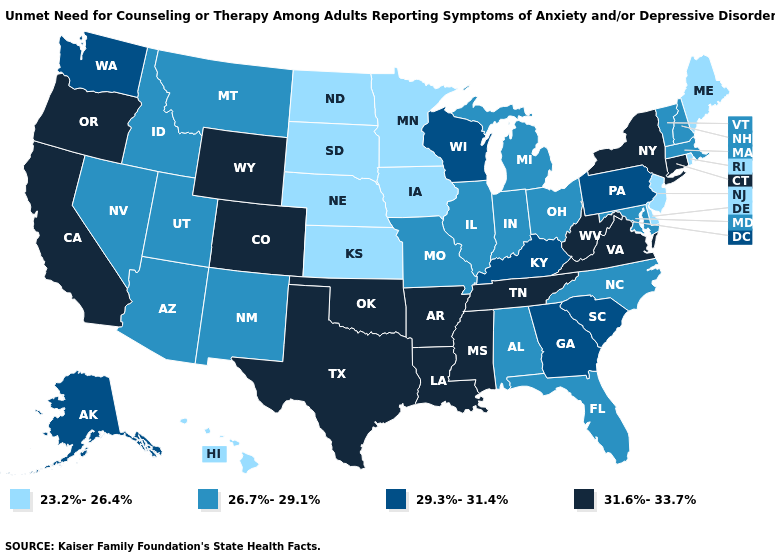Among the states that border Georgia , does South Carolina have the lowest value?
Keep it brief. No. What is the highest value in the MidWest ?
Be succinct. 29.3%-31.4%. Does Minnesota have the highest value in the MidWest?
Quick response, please. No. Name the states that have a value in the range 31.6%-33.7%?
Concise answer only. Arkansas, California, Colorado, Connecticut, Louisiana, Mississippi, New York, Oklahoma, Oregon, Tennessee, Texas, Virginia, West Virginia, Wyoming. What is the value of West Virginia?
Be succinct. 31.6%-33.7%. Among the states that border New Hampshire , which have the lowest value?
Be succinct. Maine. What is the value of Idaho?
Answer briefly. 26.7%-29.1%. What is the highest value in the Northeast ?
Answer briefly. 31.6%-33.7%. What is the value of Minnesota?
Quick response, please. 23.2%-26.4%. Does Florida have a lower value than Maine?
Be succinct. No. Name the states that have a value in the range 26.7%-29.1%?
Quick response, please. Alabama, Arizona, Florida, Idaho, Illinois, Indiana, Maryland, Massachusetts, Michigan, Missouri, Montana, Nevada, New Hampshire, New Mexico, North Carolina, Ohio, Utah, Vermont. Among the states that border Idaho , does Oregon have the highest value?
Keep it brief. Yes. What is the value of Minnesota?
Be succinct. 23.2%-26.4%. How many symbols are there in the legend?
Answer briefly. 4. 